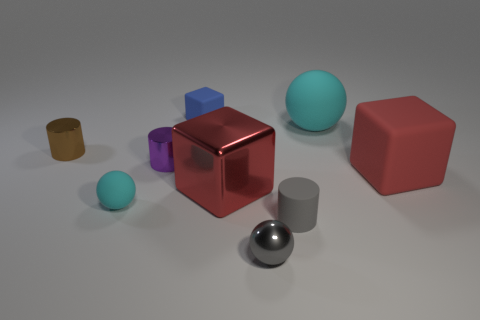What number of things are made of the same material as the small gray sphere?
Provide a short and direct response. 3. There is a matte object that is the same color as the shiny block; what is its shape?
Provide a short and direct response. Cube. There is a matte block that is in front of the big object that is behind the small brown cylinder; what is its size?
Make the answer very short. Large. There is a small shiny thing that is in front of the small cyan ball; is its shape the same as the red object left of the gray rubber cylinder?
Provide a succinct answer. No. Is the number of red matte things that are on the left side of the blue rubber object the same as the number of tiny gray rubber objects?
Your response must be concise. No. What is the color of the other rubber thing that is the same shape as the brown object?
Keep it short and to the point. Gray. Are the red object in front of the large red rubber cube and the blue thing made of the same material?
Ensure brevity in your answer.  No. What number of small things are either gray shiny things or purple things?
Provide a succinct answer. 2. What is the size of the gray sphere?
Offer a terse response. Small. Is the size of the purple shiny thing the same as the cyan object on the right side of the blue object?
Ensure brevity in your answer.  No. 